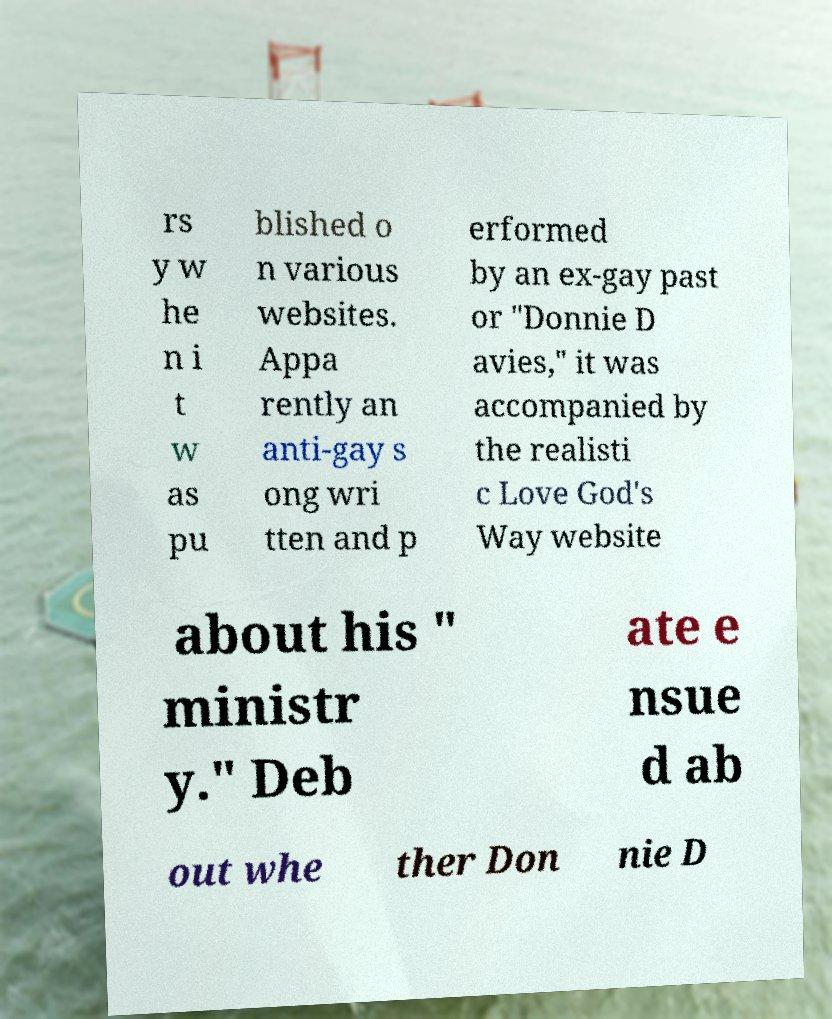There's text embedded in this image that I need extracted. Can you transcribe it verbatim? rs y w he n i t w as pu blished o n various websites. Appa rently an anti-gay s ong wri tten and p erformed by an ex-gay past or "Donnie D avies," it was accompanied by the realisti c Love God's Way website about his " ministr y." Deb ate e nsue d ab out whe ther Don nie D 